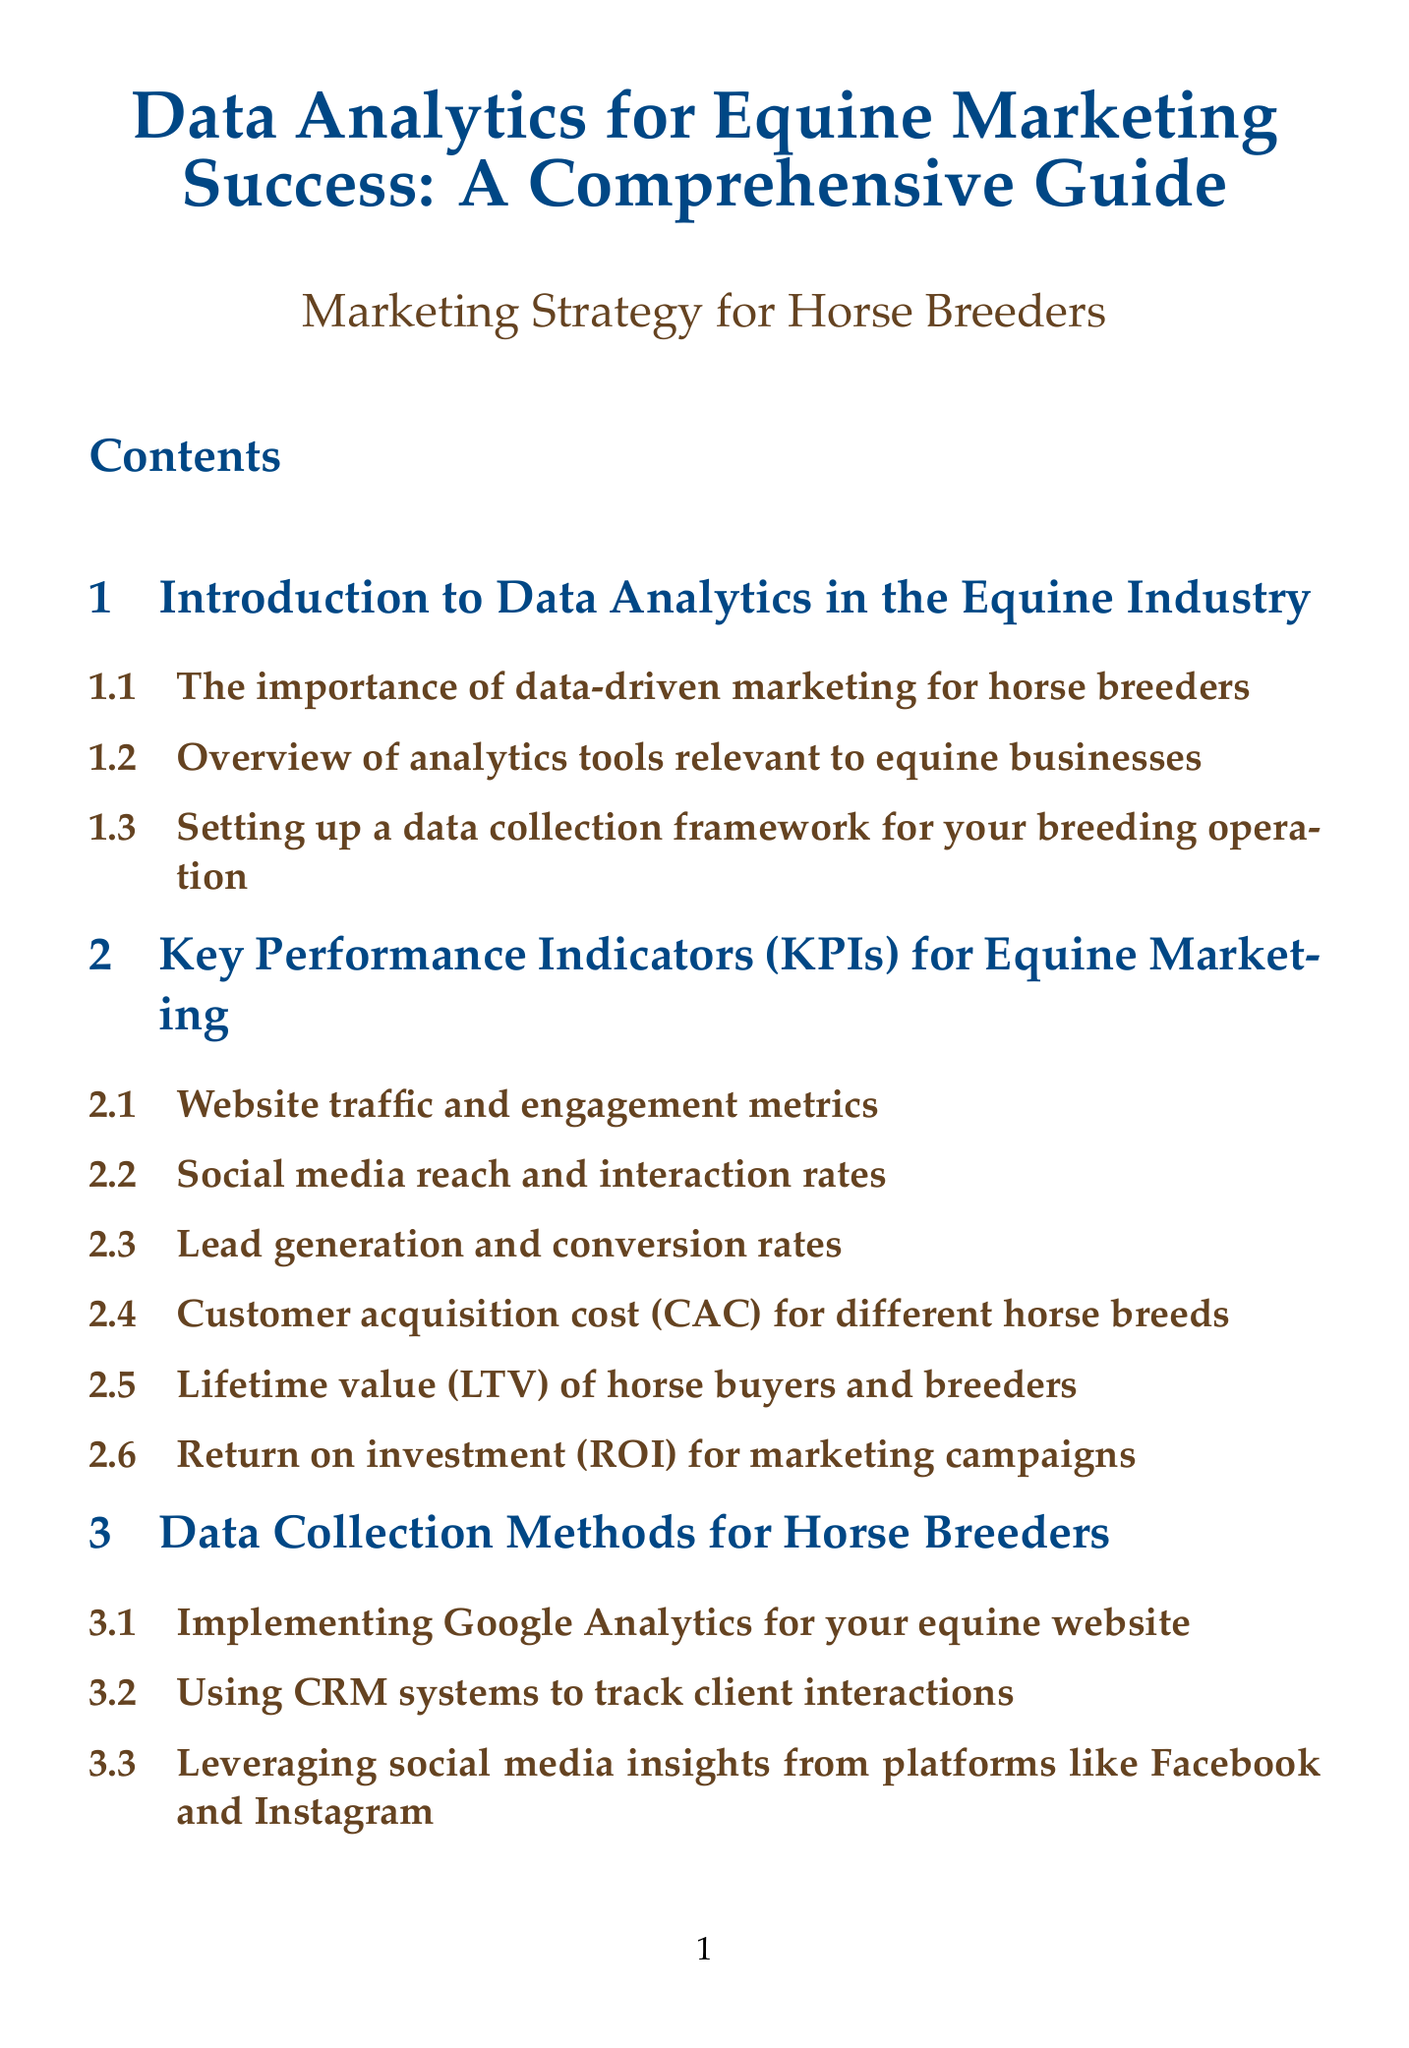What is the title of the manual? The title of the manual is stated at the beginning of the document.
Answer: Data Analytics for Equine Marketing Success: A Comprehensive Guide How many chapters are in the manual? The total number of chapters is explicitly mentioned in the document.
Answer: Nine Which chapter discusses ethical considerations in equine marketing? The chapter that addresses ethical considerations is noted in the document.
Answer: Ethical Considerations and Data Privacy in Equine Marketing What is one method for data collection mentioned for horse breeders? The document lists various methods for collecting data, one of which is highlighted.
Answer: Implementing Google Analytics for your equine website What does "LTV" stand for in the context of equine marketing KPIs? The abbreviation "LTV" is explained within the relevant section in the document.
Answer: Lifetime value Which appendix contains a glossary of marketing terms? The specific appendix providing a glossary can be identified in the appendices section.
Answer: Appendix D: Glossary of Equine Marketing Terms What is a resource mentioned for mastering web analytics? The document provides specific resources related to web analytics, one of which is named.
Answer: Google Analytics Academy How many case studies are presented in the manual? The number of case studies is indicated in the document's section on case studies.
Answer: Three What are the future trends discussed related to equine marketing analytics? The manual outlines future trends in its last chapter, generally focusing on new technologies.
Answer: Artificial intelligence and machine learning applications 